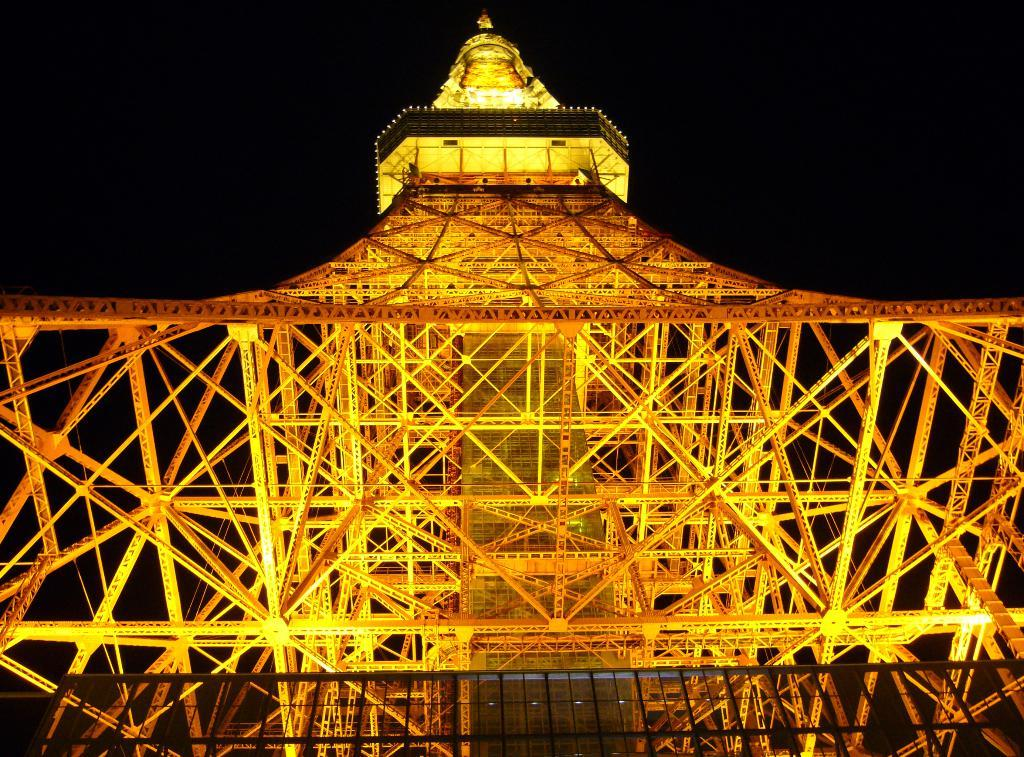What is the main structure in the image? There is a huge metal tower in the image. What colors are used for the tower? The tower is brown and yellow in color, with yellow color elements. Are there any lights on the tower? Yes, there are lights on the tower. What can be seen in the background of the image? The sky in the background is dark. What type of lace is draped over the tower in the image? There is no lace present in the image; the tower is made of metal and has lights and color elements. Is there a party happening near the tower in the image? There is no indication of a party in the image; it only shows the tower and the dark sky in the background. 